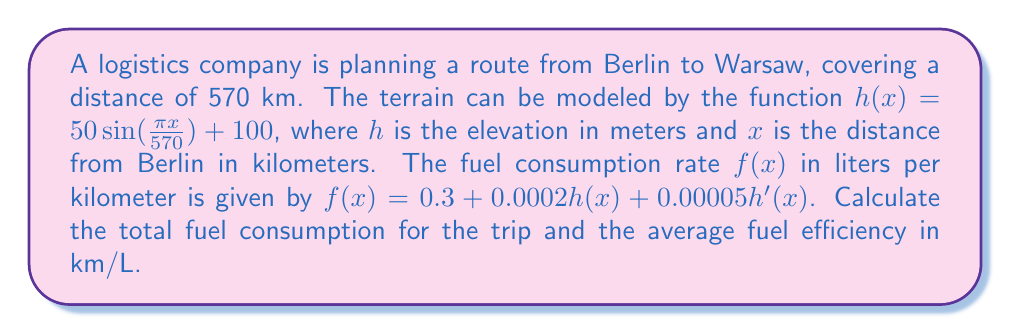Can you solve this math problem? To solve this problem, we need to follow these steps:

1) First, we need to calculate the total fuel consumption. This can be done by integrating the fuel consumption rate over the entire distance:

   $$\text{Total Fuel} = \int_0^{570} f(x) dx$$

2) Let's expand $f(x)$:
   
   $$f(x) = 0.3 + 0.0002(50 \sin(\frac{\pi x}{570}) + 100) + 0.00005(50 \cdot \frac{\pi}{570} \cos(\frac{\pi x}{570}))$$
   
   $$f(x) = 0.3 + 0.01 + 0.0001 \sin(\frac{\pi x}{570}) + 0.00000436 \cos(\frac{\pi x}{570})$$
   
   $$f(x) = 0.31 + 0.0001 \sin(\frac{\pi x}{570}) + 0.00000436 \cos(\frac{\pi x}{570})$$

3) Now we can integrate:

   $$\text{Total Fuel} = \int_0^{570} (0.31 + 0.0001 \sin(\frac{\pi x}{570}) + 0.00000436 \cos(\frac{\pi x}{570})) dx$$
   
   $$= [0.31x - 0.0001 \cdot \frac{570}{\pi} \cos(\frac{\pi x}{570}) + 0.00000436 \cdot \frac{570}{\pi} \sin(\frac{\pi x}{570})]_0^{570}$$
   
   $$= (176.7 + 0 + 0) - (0 + 0.018 - 0)$$
   
   $$= 176.682 \text{ liters}$$

4) To calculate the average fuel efficiency, we divide the total distance by the total fuel consumption:

   $$\text{Efficiency} = \frac{570}{176.682} = 3.226 \text{ km/L}$$
Answer: 176.682 L; 3.226 km/L 